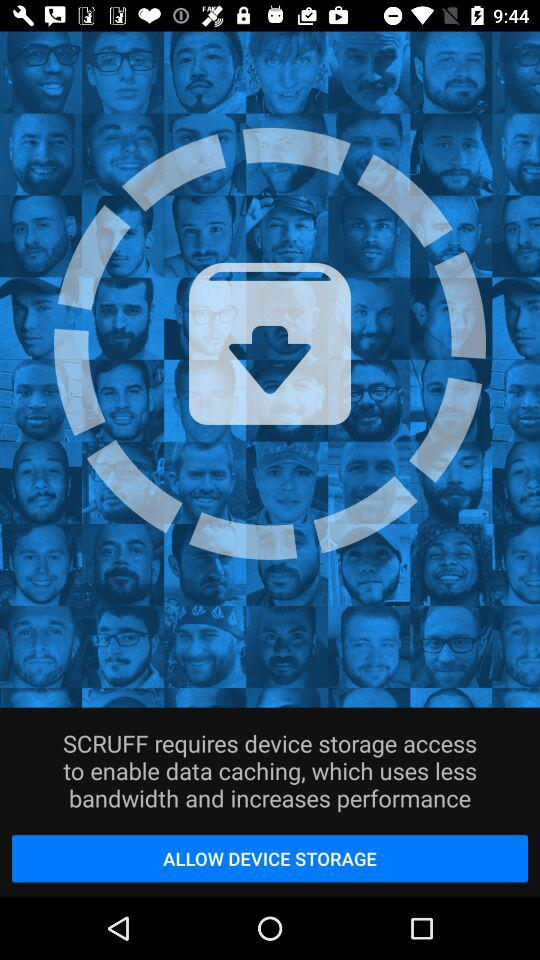What is the name of the application? The name of the application is "SCRUFF". 